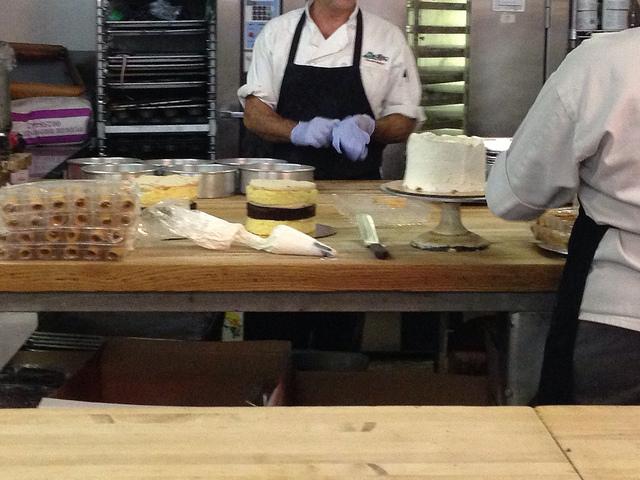What color are the gloves the person has on?
Be succinct. White. How many people are cutting some cake?
Concise answer only. 1. Is that a wood counter?
Keep it brief. Yes. What kind of kitchen is this?
Short answer required. Bakery. What food is the couple making?
Keep it brief. Cake. 